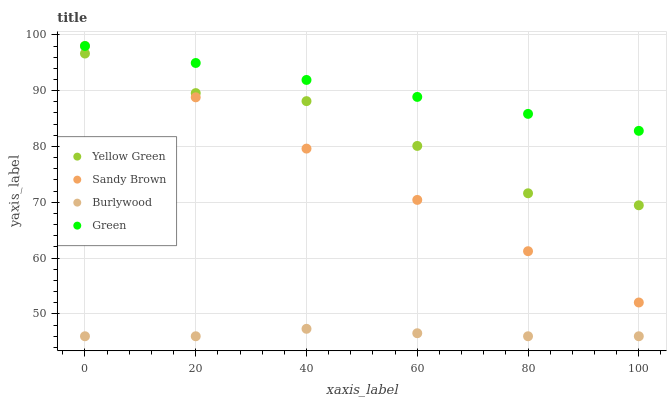Does Burlywood have the minimum area under the curve?
Answer yes or no. Yes. Does Green have the maximum area under the curve?
Answer yes or no. Yes. Does Sandy Brown have the minimum area under the curve?
Answer yes or no. No. Does Sandy Brown have the maximum area under the curve?
Answer yes or no. No. Is Sandy Brown the smoothest?
Answer yes or no. Yes. Is Yellow Green the roughest?
Answer yes or no. Yes. Is Green the smoothest?
Answer yes or no. No. Is Green the roughest?
Answer yes or no. No. Does Burlywood have the lowest value?
Answer yes or no. Yes. Does Sandy Brown have the lowest value?
Answer yes or no. No. Does Sandy Brown have the highest value?
Answer yes or no. Yes. Does Yellow Green have the highest value?
Answer yes or no. No. Is Burlywood less than Green?
Answer yes or no. Yes. Is Green greater than Yellow Green?
Answer yes or no. Yes. Does Sandy Brown intersect Green?
Answer yes or no. Yes. Is Sandy Brown less than Green?
Answer yes or no. No. Is Sandy Brown greater than Green?
Answer yes or no. No. Does Burlywood intersect Green?
Answer yes or no. No. 